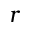<formula> <loc_0><loc_0><loc_500><loc_500>r</formula> 